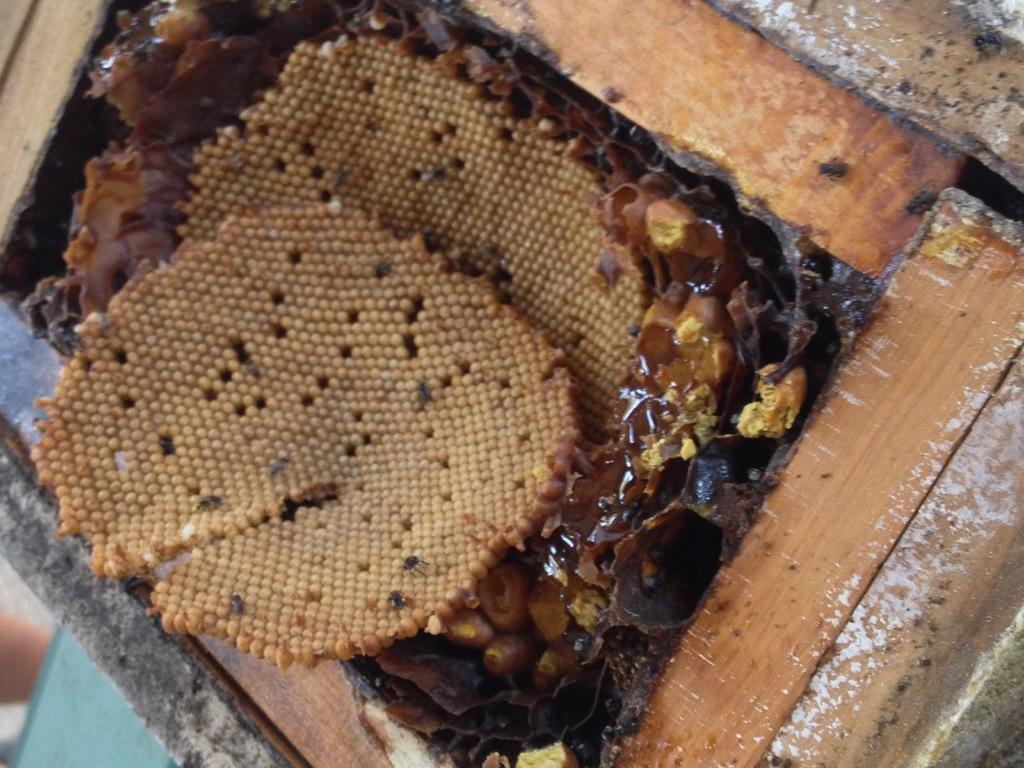Can you describe this image briefly? In this picture we can see honey bee hives, wooden sticks and some objects. 